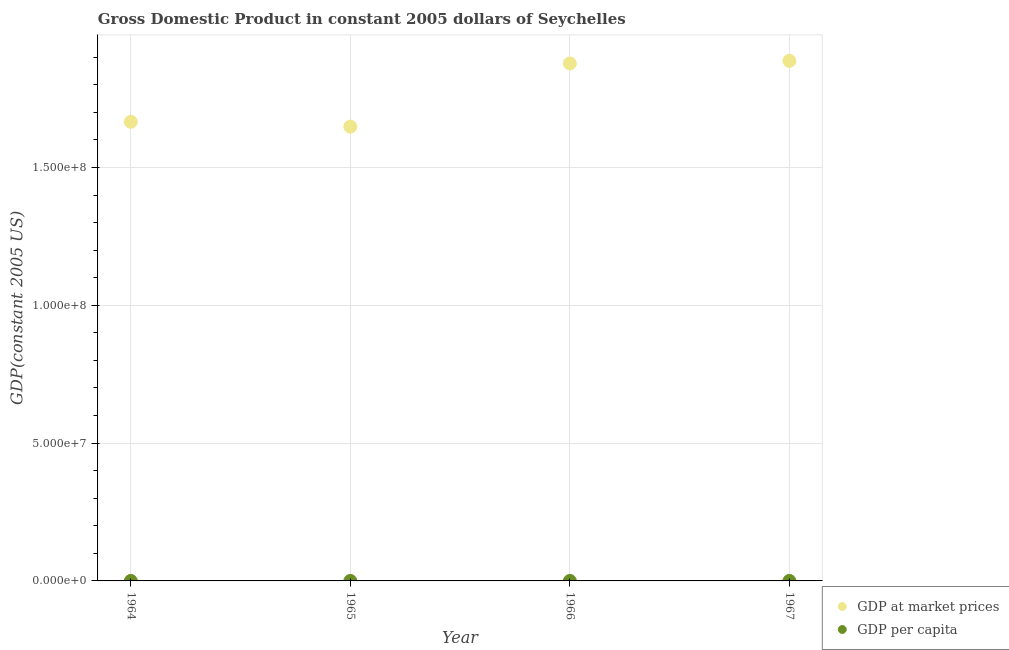How many different coloured dotlines are there?
Keep it short and to the point. 2. What is the gdp at market prices in 1965?
Offer a very short reply. 1.65e+08. Across all years, what is the maximum gdp per capita?
Offer a terse response. 3855.14. Across all years, what is the minimum gdp per capita?
Give a very brief answer. 3470.21. In which year was the gdp at market prices maximum?
Make the answer very short. 1967. In which year was the gdp at market prices minimum?
Your answer should be compact. 1965. What is the total gdp at market prices in the graph?
Your answer should be very brief. 7.08e+08. What is the difference between the gdp per capita in 1964 and that in 1965?
Keep it short and to the point. 126.39. What is the difference between the gdp per capita in 1966 and the gdp at market prices in 1965?
Keep it short and to the point. -1.65e+08. What is the average gdp at market prices per year?
Your answer should be very brief. 1.77e+08. In the year 1966, what is the difference between the gdp per capita and gdp at market prices?
Ensure brevity in your answer.  -1.88e+08. What is the ratio of the gdp per capita in 1966 to that in 1967?
Keep it short and to the point. 1.02. Is the gdp per capita in 1966 less than that in 1967?
Your answer should be very brief. No. Is the difference between the gdp per capita in 1966 and 1967 greater than the difference between the gdp at market prices in 1966 and 1967?
Offer a very short reply. Yes. What is the difference between the highest and the second highest gdp per capita?
Your response must be concise. 74.63. What is the difference between the highest and the lowest gdp at market prices?
Your answer should be very brief. 2.39e+07. Is the gdp per capita strictly greater than the gdp at market prices over the years?
Provide a succinct answer. No. Is the gdp per capita strictly less than the gdp at market prices over the years?
Provide a succinct answer. Yes. How many dotlines are there?
Ensure brevity in your answer.  2. How many years are there in the graph?
Give a very brief answer. 4. What is the difference between two consecutive major ticks on the Y-axis?
Your answer should be compact. 5.00e+07. Where does the legend appear in the graph?
Provide a short and direct response. Bottom right. What is the title of the graph?
Ensure brevity in your answer.  Gross Domestic Product in constant 2005 dollars of Seychelles. Does "All education staff compensation" appear as one of the legend labels in the graph?
Offer a terse response. No. What is the label or title of the X-axis?
Offer a terse response. Year. What is the label or title of the Y-axis?
Provide a short and direct response. GDP(constant 2005 US). What is the GDP(constant 2005 US) of GDP at market prices in 1964?
Offer a terse response. 1.67e+08. What is the GDP(constant 2005 US) of GDP per capita in 1964?
Your answer should be very brief. 3596.61. What is the GDP(constant 2005 US) in GDP at market prices in 1965?
Make the answer very short. 1.65e+08. What is the GDP(constant 2005 US) in GDP per capita in 1965?
Offer a terse response. 3470.21. What is the GDP(constant 2005 US) of GDP at market prices in 1966?
Give a very brief answer. 1.88e+08. What is the GDP(constant 2005 US) of GDP per capita in 1966?
Your response must be concise. 3855.14. What is the GDP(constant 2005 US) of GDP at market prices in 1967?
Provide a short and direct response. 1.89e+08. What is the GDP(constant 2005 US) in GDP per capita in 1967?
Your answer should be very brief. 3780.51. Across all years, what is the maximum GDP(constant 2005 US) in GDP at market prices?
Provide a short and direct response. 1.89e+08. Across all years, what is the maximum GDP(constant 2005 US) of GDP per capita?
Your answer should be very brief. 3855.14. Across all years, what is the minimum GDP(constant 2005 US) in GDP at market prices?
Give a very brief answer. 1.65e+08. Across all years, what is the minimum GDP(constant 2005 US) of GDP per capita?
Provide a short and direct response. 3470.21. What is the total GDP(constant 2005 US) in GDP at market prices in the graph?
Ensure brevity in your answer.  7.08e+08. What is the total GDP(constant 2005 US) of GDP per capita in the graph?
Offer a terse response. 1.47e+04. What is the difference between the GDP(constant 2005 US) of GDP at market prices in 1964 and that in 1965?
Give a very brief answer. 1.77e+06. What is the difference between the GDP(constant 2005 US) in GDP per capita in 1964 and that in 1965?
Your answer should be compact. 126.39. What is the difference between the GDP(constant 2005 US) of GDP at market prices in 1964 and that in 1966?
Offer a very short reply. -2.11e+07. What is the difference between the GDP(constant 2005 US) of GDP per capita in 1964 and that in 1966?
Offer a very short reply. -258.53. What is the difference between the GDP(constant 2005 US) of GDP at market prices in 1964 and that in 1967?
Offer a terse response. -2.21e+07. What is the difference between the GDP(constant 2005 US) in GDP per capita in 1964 and that in 1967?
Give a very brief answer. -183.9. What is the difference between the GDP(constant 2005 US) in GDP at market prices in 1965 and that in 1966?
Give a very brief answer. -2.29e+07. What is the difference between the GDP(constant 2005 US) in GDP per capita in 1965 and that in 1966?
Offer a terse response. -384.93. What is the difference between the GDP(constant 2005 US) of GDP at market prices in 1965 and that in 1967?
Keep it short and to the point. -2.39e+07. What is the difference between the GDP(constant 2005 US) in GDP per capita in 1965 and that in 1967?
Your answer should be compact. -310.3. What is the difference between the GDP(constant 2005 US) in GDP at market prices in 1966 and that in 1967?
Your answer should be compact. -9.48e+05. What is the difference between the GDP(constant 2005 US) in GDP per capita in 1966 and that in 1967?
Keep it short and to the point. 74.63. What is the difference between the GDP(constant 2005 US) in GDP at market prices in 1964 and the GDP(constant 2005 US) in GDP per capita in 1965?
Your answer should be compact. 1.67e+08. What is the difference between the GDP(constant 2005 US) in GDP at market prices in 1964 and the GDP(constant 2005 US) in GDP per capita in 1966?
Your response must be concise. 1.67e+08. What is the difference between the GDP(constant 2005 US) of GDP at market prices in 1964 and the GDP(constant 2005 US) of GDP per capita in 1967?
Give a very brief answer. 1.67e+08. What is the difference between the GDP(constant 2005 US) in GDP at market prices in 1965 and the GDP(constant 2005 US) in GDP per capita in 1966?
Provide a succinct answer. 1.65e+08. What is the difference between the GDP(constant 2005 US) of GDP at market prices in 1965 and the GDP(constant 2005 US) of GDP per capita in 1967?
Give a very brief answer. 1.65e+08. What is the difference between the GDP(constant 2005 US) in GDP at market prices in 1966 and the GDP(constant 2005 US) in GDP per capita in 1967?
Provide a succinct answer. 1.88e+08. What is the average GDP(constant 2005 US) in GDP at market prices per year?
Provide a succinct answer. 1.77e+08. What is the average GDP(constant 2005 US) of GDP per capita per year?
Offer a terse response. 3675.62. In the year 1964, what is the difference between the GDP(constant 2005 US) of GDP at market prices and GDP(constant 2005 US) of GDP per capita?
Offer a terse response. 1.67e+08. In the year 1965, what is the difference between the GDP(constant 2005 US) in GDP at market prices and GDP(constant 2005 US) in GDP per capita?
Ensure brevity in your answer.  1.65e+08. In the year 1966, what is the difference between the GDP(constant 2005 US) in GDP at market prices and GDP(constant 2005 US) in GDP per capita?
Offer a very short reply. 1.88e+08. In the year 1967, what is the difference between the GDP(constant 2005 US) in GDP at market prices and GDP(constant 2005 US) in GDP per capita?
Provide a succinct answer. 1.89e+08. What is the ratio of the GDP(constant 2005 US) in GDP at market prices in 1964 to that in 1965?
Your answer should be compact. 1.01. What is the ratio of the GDP(constant 2005 US) in GDP per capita in 1964 to that in 1965?
Your response must be concise. 1.04. What is the ratio of the GDP(constant 2005 US) of GDP at market prices in 1964 to that in 1966?
Provide a succinct answer. 0.89. What is the ratio of the GDP(constant 2005 US) of GDP per capita in 1964 to that in 1966?
Your answer should be compact. 0.93. What is the ratio of the GDP(constant 2005 US) of GDP at market prices in 1964 to that in 1967?
Keep it short and to the point. 0.88. What is the ratio of the GDP(constant 2005 US) in GDP per capita in 1964 to that in 1967?
Your response must be concise. 0.95. What is the ratio of the GDP(constant 2005 US) in GDP at market prices in 1965 to that in 1966?
Offer a very short reply. 0.88. What is the ratio of the GDP(constant 2005 US) in GDP per capita in 1965 to that in 1966?
Provide a short and direct response. 0.9. What is the ratio of the GDP(constant 2005 US) of GDP at market prices in 1965 to that in 1967?
Your answer should be compact. 0.87. What is the ratio of the GDP(constant 2005 US) of GDP per capita in 1965 to that in 1967?
Your answer should be compact. 0.92. What is the ratio of the GDP(constant 2005 US) in GDP at market prices in 1966 to that in 1967?
Keep it short and to the point. 0.99. What is the ratio of the GDP(constant 2005 US) of GDP per capita in 1966 to that in 1967?
Your response must be concise. 1.02. What is the difference between the highest and the second highest GDP(constant 2005 US) in GDP at market prices?
Your answer should be compact. 9.48e+05. What is the difference between the highest and the second highest GDP(constant 2005 US) in GDP per capita?
Your response must be concise. 74.63. What is the difference between the highest and the lowest GDP(constant 2005 US) of GDP at market prices?
Offer a terse response. 2.39e+07. What is the difference between the highest and the lowest GDP(constant 2005 US) of GDP per capita?
Give a very brief answer. 384.93. 